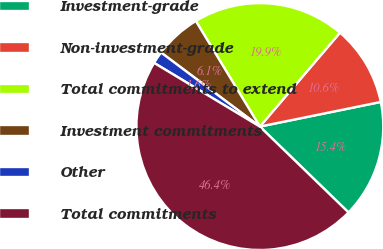Convert chart. <chart><loc_0><loc_0><loc_500><loc_500><pie_chart><fcel>Investment-grade<fcel>Non-investment-grade<fcel>Total commitments to extend<fcel>Investment commitments<fcel>Other<fcel>Total commitments<nl><fcel>15.44%<fcel>10.56%<fcel>19.92%<fcel>6.09%<fcel>1.61%<fcel>46.38%<nl></chart> 